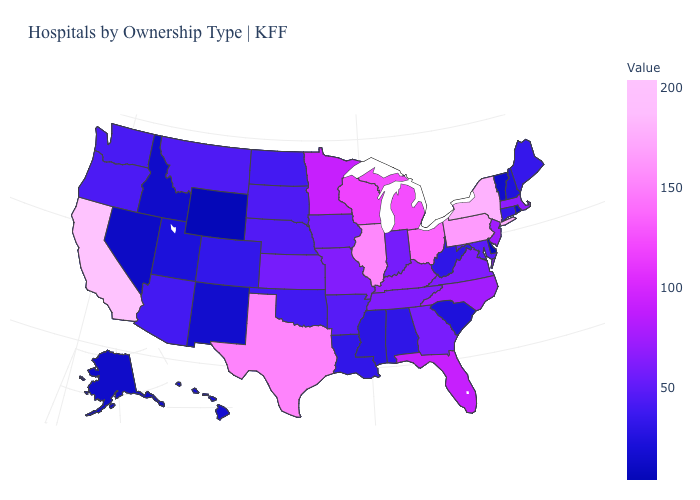Which states hav the highest value in the West?
Short answer required. California. Which states have the highest value in the USA?
Answer briefly. California. Among the states that border Pennsylvania , which have the highest value?
Be succinct. New York. Does Louisiana have the highest value in the USA?
Short answer required. No. Which states have the highest value in the USA?
Answer briefly. California. 